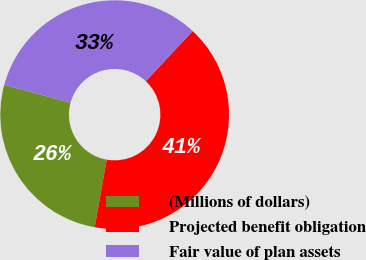<chart> <loc_0><loc_0><loc_500><loc_500><pie_chart><fcel>(Millions of dollars)<fcel>Projected benefit obligation<fcel>Fair value of plan assets<nl><fcel>26.41%<fcel>40.85%<fcel>32.74%<nl></chart> 